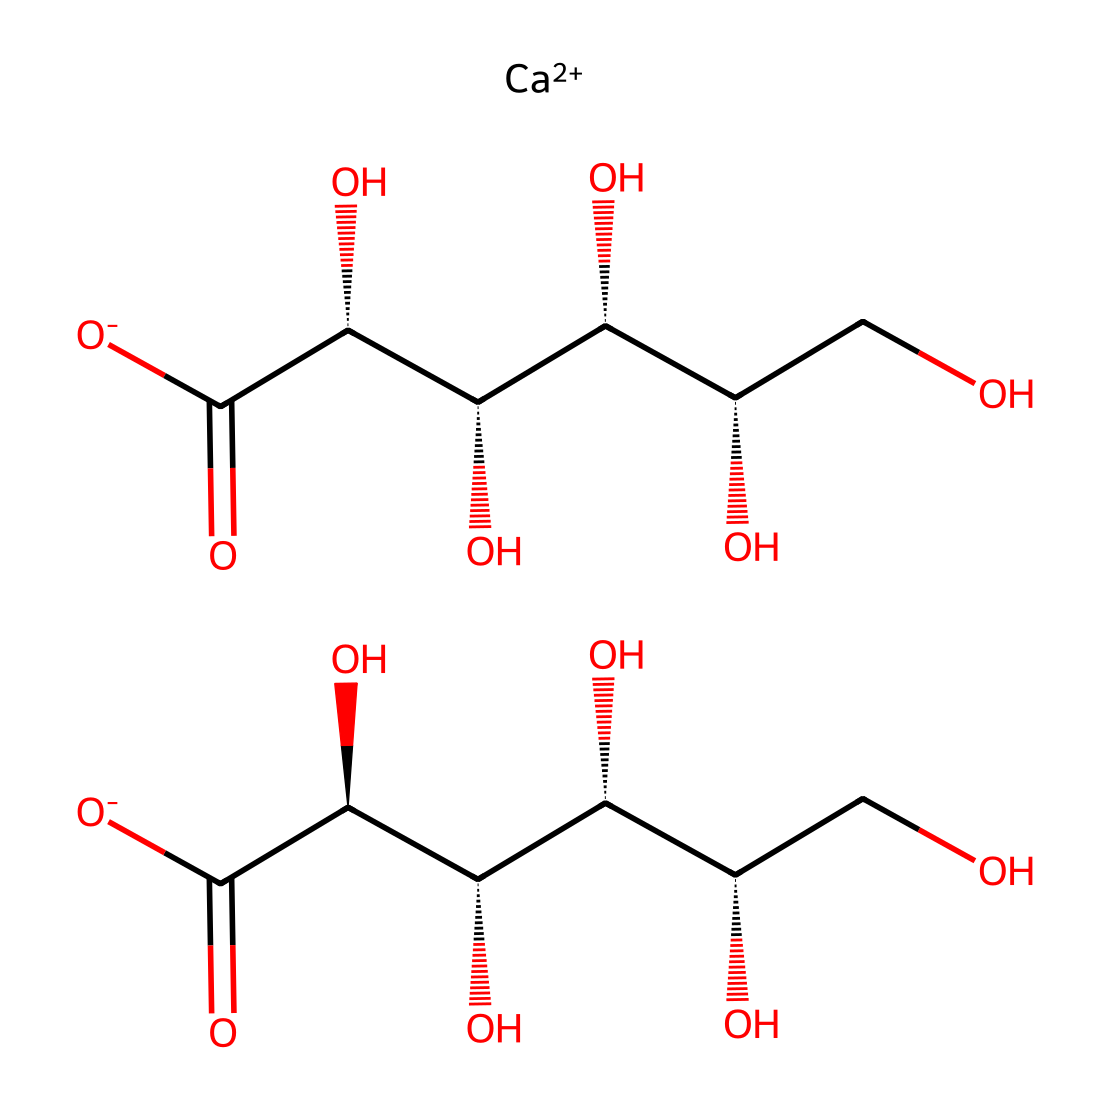What is the molecular formula of calcium gluconate? The vascular representation of the chemical structure reveals the presence of calcium and glucose components. The breakdown shows two gluconate units each represented as C6H10O6, combined with one Ca atom. Thus, the complete molecular formula becomes C12H22CaO14.
Answer: C12H22CaO14 How many chiral centers are present in calcium gluconate? By examining the SMILES representation and the stereocenters (indicated by the *@* symbols), we can identify that there are a total of 5 chiral centers due to the presence of five carbon atoms bonded to four different substituents.
Answer: 5 What type of chemical bonding can be observed in calcium gluconate? The presence of multiple hydroxyl (-OH) groups, along with the carboxyl (-COO-) groups and the coordination of calcium (Ca++) indicates that the molecule features both ionic bonds (between Ca++ and the anions) and covalent bonds (within the glucose moieties).
Answer: ionic and covalent What primarily contributes to the electrolyte function of calcium gluconate? The ability of calcium to dissociate into calcium ions (Ca++) upon dissolving in water allows it to conduct electricity, which is a characteristic of electrolytes. This dissociation is pivotal in its role as an electrolyte.
Answer: calcium ions What is the significance of the hydroxyl groups in the structure? The hydroxyl groups present in calcium gluconate enhance its solubility in water and play a crucial role in the molecule's reactivity and its ability to participate in biochemical processes, such as acting in energy metabolism and maintaining electrolyte balance.
Answer: solubility and reactivity Which part of the structure represents the gluconate ion? The right side of the SMILES representation captures the gluconate moiety, which consists of a carbohydrate structure (with multiple hydroxyl groups) and a carboxylate functional group, reflecting its deprotonated state as an ion.
Answer: gluconate moiety 